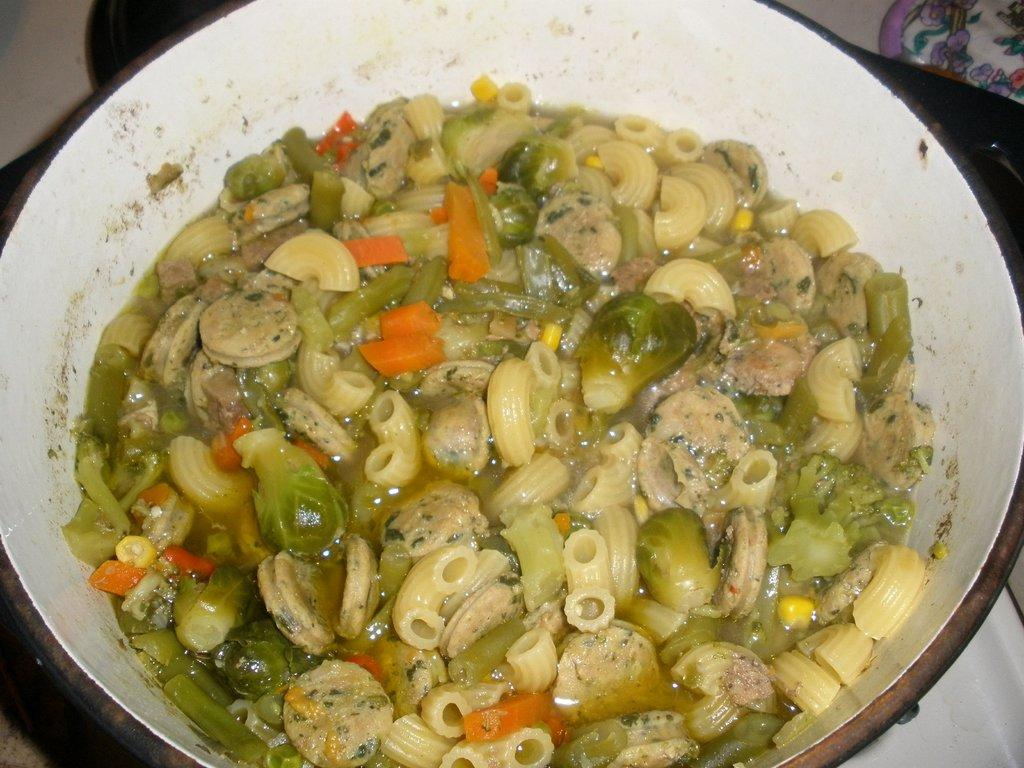What color is the plate in the image? The plate in the image is white colored. What is on the plate? The plate contains a food item. Can you describe the food item on the plate? The food item has cream, orange, green, and yellow colors. What else can be seen in the background of the image? There are other objects visible in the background of the image. How does the wind affect the food item on the plate in the image? There is no wind present in the image, so it cannot affect the food item on the plate. 